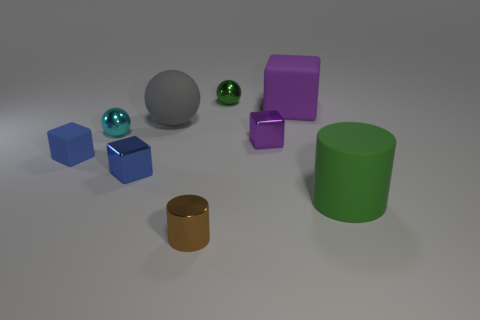Add 1 small purple metal blocks. How many objects exist? 10 Subtract all tiny balls. How many balls are left? 1 Subtract 2 balls. How many balls are left? 1 Subtract all cubes. How many objects are left? 5 Subtract all gray blocks. Subtract all green cylinders. How many blocks are left? 4 Subtract all blue blocks. How many brown balls are left? 0 Subtract all small yellow things. Subtract all tiny matte things. How many objects are left? 8 Add 5 green rubber cylinders. How many green rubber cylinders are left? 6 Add 6 green metallic cubes. How many green metallic cubes exist? 6 Subtract all cyan balls. How many balls are left? 2 